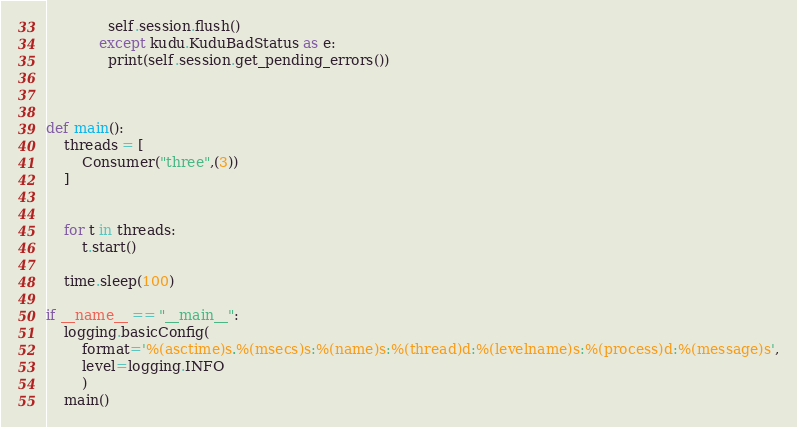Convert code to text. <code><loc_0><loc_0><loc_500><loc_500><_Python_>              self.session.flush()
            except kudu.KuduBadStatus as e:
              print(self.session.get_pending_errors())



def main():
    threads = [
        Consumer("three",(3))
    ]


    for t in threads:
        t.start()

    time.sleep(100)

if __name__ == "__main__":
    logging.basicConfig(
        format='%(asctime)s.%(msecs)s:%(name)s:%(thread)d:%(levelname)s:%(process)d:%(message)s',
        level=logging.INFO
        )
    main()
</code> 